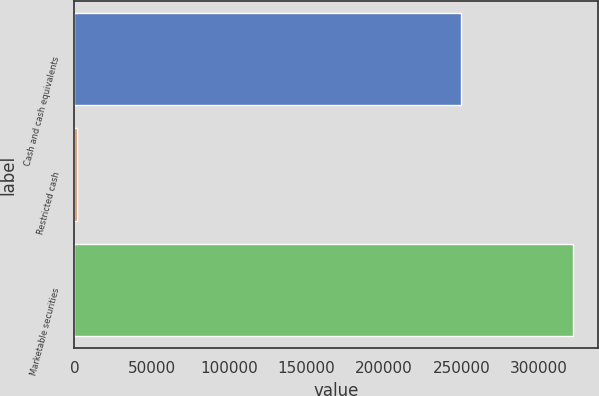Convert chart to OTSL. <chart><loc_0><loc_0><loc_500><loc_500><bar_chart><fcel>Cash and cash equivalents<fcel>Restricted cash<fcel>Marketable securities<nl><fcel>249909<fcel>1457<fcel>322215<nl></chart> 